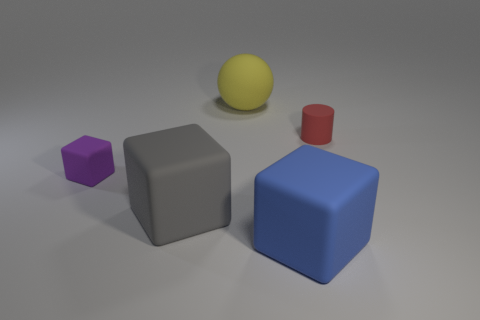The matte ball has what size?
Ensure brevity in your answer.  Large. Does the block right of the large gray matte block have the same material as the large sphere?
Your answer should be compact. Yes. The small rubber object that is the same shape as the big blue rubber thing is what color?
Your response must be concise. Purple. There is a rubber cube to the right of the large yellow rubber ball; is it the same color as the tiny rubber cube?
Offer a terse response. No. There is a large gray cube; are there any gray rubber blocks left of it?
Provide a short and direct response. No. What is the color of the matte block that is to the right of the tiny block and to the left of the big ball?
Ensure brevity in your answer.  Gray. There is a purple matte block that is in front of the rubber thing behind the small red matte object; what is its size?
Give a very brief answer. Small. How many balls are either purple matte things or large gray matte things?
Provide a short and direct response. 0. What color is the other object that is the same size as the red thing?
Keep it short and to the point. Purple. What shape is the tiny rubber thing to the right of the large block on the left side of the large yellow matte object?
Give a very brief answer. Cylinder. 